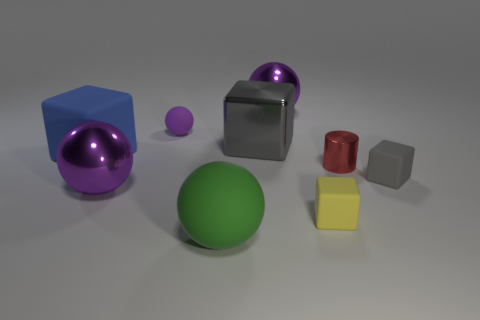Subtract all purple blocks. How many purple balls are left? 3 Add 1 gray matte things. How many objects exist? 10 Subtract all cylinders. How many objects are left? 8 Add 6 blue rubber objects. How many blue rubber objects are left? 7 Add 9 tiny metal objects. How many tiny metal objects exist? 10 Subtract 0 yellow cylinders. How many objects are left? 9 Subtract all tiny purple rubber balls. Subtract all large green metallic objects. How many objects are left? 8 